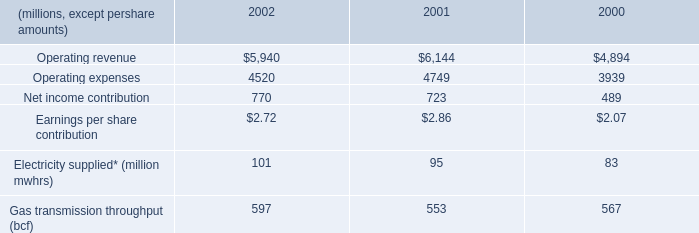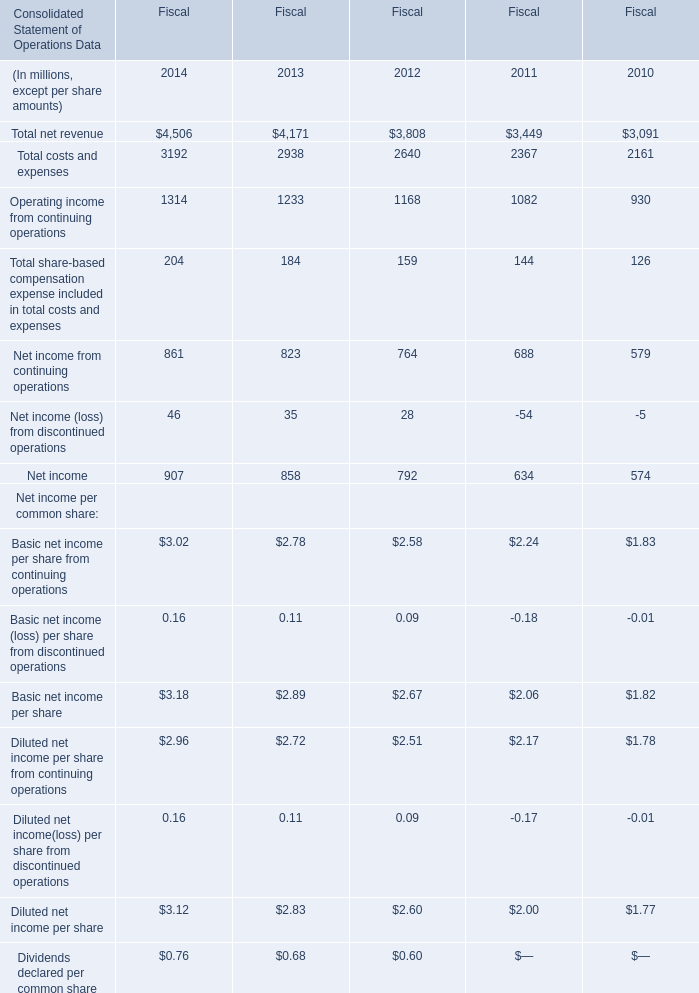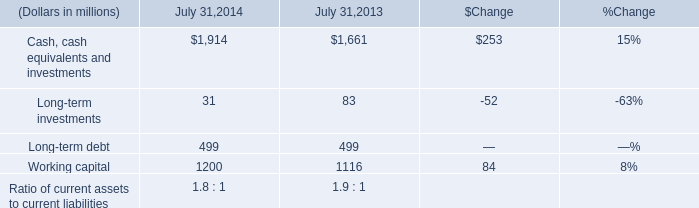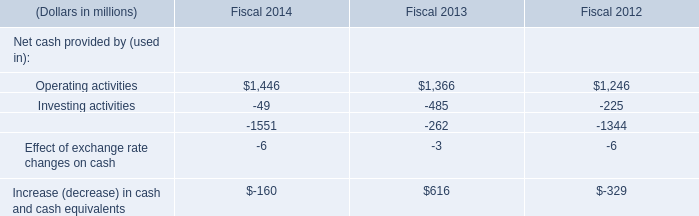if the 2003 growth rate is the same as 2002 , what would 2003 gas transmission throughput be in bcf?\\n 
Computations: ((597 / 553) * 597)
Answer: 644.5009. The Net income of which year ranks first for Fiscal? 
Answer: 2014. 